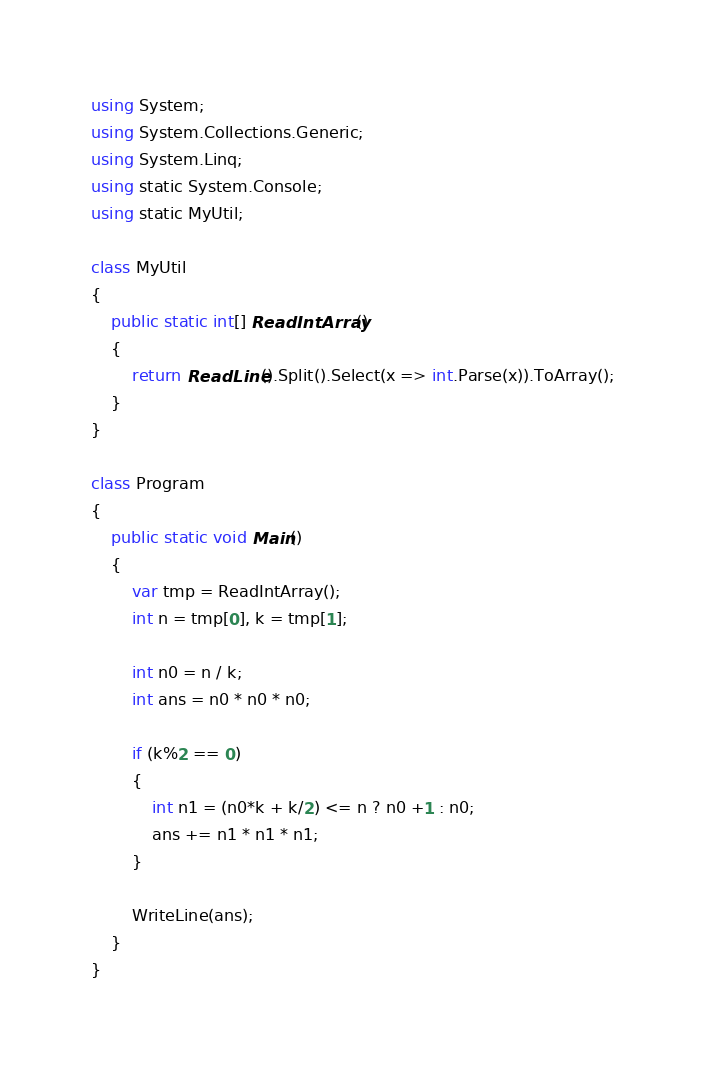Convert code to text. <code><loc_0><loc_0><loc_500><loc_500><_C#_>
using System;
using System.Collections.Generic;
using System.Linq;
using static System.Console;
using static MyUtil;

class MyUtil
{
    public static int[] ReadIntArray()
    {
        return ReadLine().Split().Select(x => int.Parse(x)).ToArray();
    }
}

class Program
{
    public static void Main()
    {
        var tmp = ReadIntArray();
        int n = tmp[0], k = tmp[1];

        int n0 = n / k;
        int ans = n0 * n0 * n0;

        if (k%2 == 0)
        {
            int n1 = (n0*k + k/2) <= n ? n0 +1 : n0;
            ans += n1 * n1 * n1;
        }

        WriteLine(ans);
    }
}

</code> 